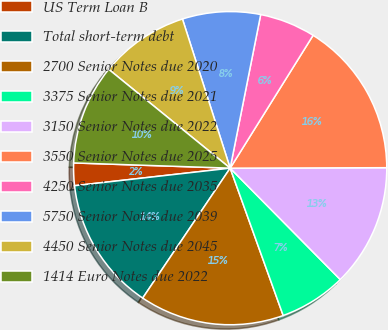Convert chart. <chart><loc_0><loc_0><loc_500><loc_500><pie_chart><fcel>US Term Loan B<fcel>Total short-term debt<fcel>2700 Senior Notes due 2020<fcel>3375 Senior Notes due 2021<fcel>3150 Senior Notes due 2022<fcel>3550 Senior Notes due 2025<fcel>4250 Senior Notes due 2035<fcel>5750 Senior Notes due 2039<fcel>4450 Senior Notes due 2045<fcel>1414 Euro Notes due 2022<nl><fcel>2.32%<fcel>13.78%<fcel>14.93%<fcel>6.91%<fcel>12.64%<fcel>16.07%<fcel>5.76%<fcel>8.05%<fcel>9.2%<fcel>10.34%<nl></chart> 